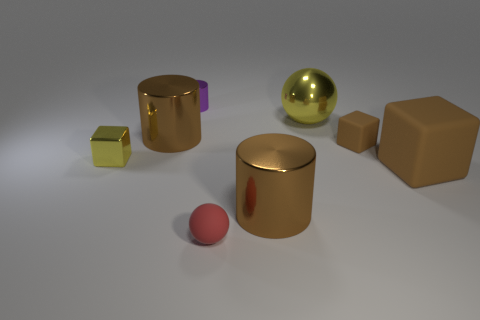What is the thing that is both to the left of the purple metal cylinder and behind the tiny brown block made of?
Give a very brief answer. Metal. There is a tiny brown object that is the same shape as the large brown rubber object; what is it made of?
Provide a short and direct response. Rubber. What number of spheres are in front of the tiny block on the left side of the brown cylinder on the left side of the purple metallic cylinder?
Provide a short and direct response. 1. Is there any other thing that is the same color as the small shiny block?
Your answer should be compact. Yes. How many things are right of the tiny purple cylinder and behind the small yellow metal block?
Provide a succinct answer. 2. There is a yellow shiny block that is to the left of the small red rubber ball; is it the same size as the red matte sphere that is in front of the small brown rubber object?
Ensure brevity in your answer.  Yes. What number of things are either cubes that are on the left side of the red object or cyan matte cubes?
Offer a very short reply. 1. What is the tiny thing that is in front of the large brown matte cube made of?
Your answer should be compact. Rubber. What is the yellow block made of?
Offer a very short reply. Metal. What material is the brown cylinder that is to the right of the tiny purple metallic thing on the right side of the yellow thing that is on the left side of the tiny purple cylinder?
Provide a succinct answer. Metal. 